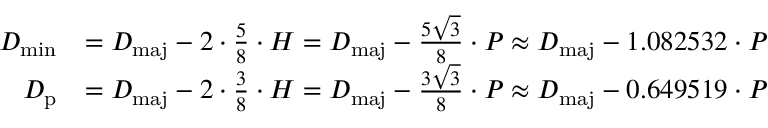<formula> <loc_0><loc_0><loc_500><loc_500>{ \begin{array} { r l } { D _ { \min } } & { = D _ { m a j } - 2 \cdot { \frac { 5 } { 8 } } \cdot H = D _ { m a j } - { \frac { 5 { \sqrt { 3 } } } { 8 } } \cdot P \approx D _ { m a j } - 1 . 0 8 2 5 3 2 \cdot P } \\ { D _ { p } } & { = D _ { m a j } - 2 \cdot { \frac { 3 } { 8 } } \cdot H = D _ { m a j } - { \frac { 3 { \sqrt { 3 } } } { 8 } } \cdot P \approx D _ { m a j } - 0 . 6 4 9 5 1 9 \cdot P } \end{array} }</formula> 